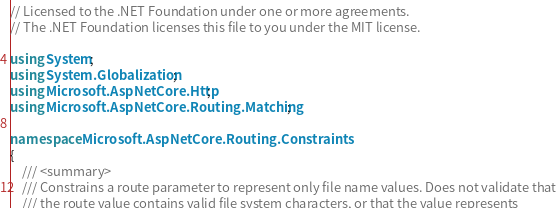<code> <loc_0><loc_0><loc_500><loc_500><_C#_>// Licensed to the .NET Foundation under one or more agreements.
// The .NET Foundation licenses this file to you under the MIT license.

using System;
using System.Globalization;
using Microsoft.AspNetCore.Http;
using Microsoft.AspNetCore.Routing.Matching;

namespace Microsoft.AspNetCore.Routing.Constraints
{
    /// <summary>
    /// Constrains a route parameter to represent only file name values. Does not validate that
    /// the route value contains valid file system characters, or that the value represents</code> 